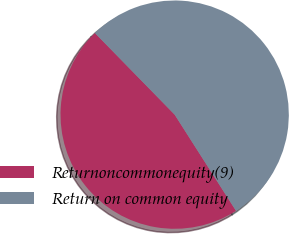Convert chart. <chart><loc_0><loc_0><loc_500><loc_500><pie_chart><fcel>Returnoncommonequity(9)<fcel>Return on common equity<nl><fcel>46.72%<fcel>53.28%<nl></chart> 